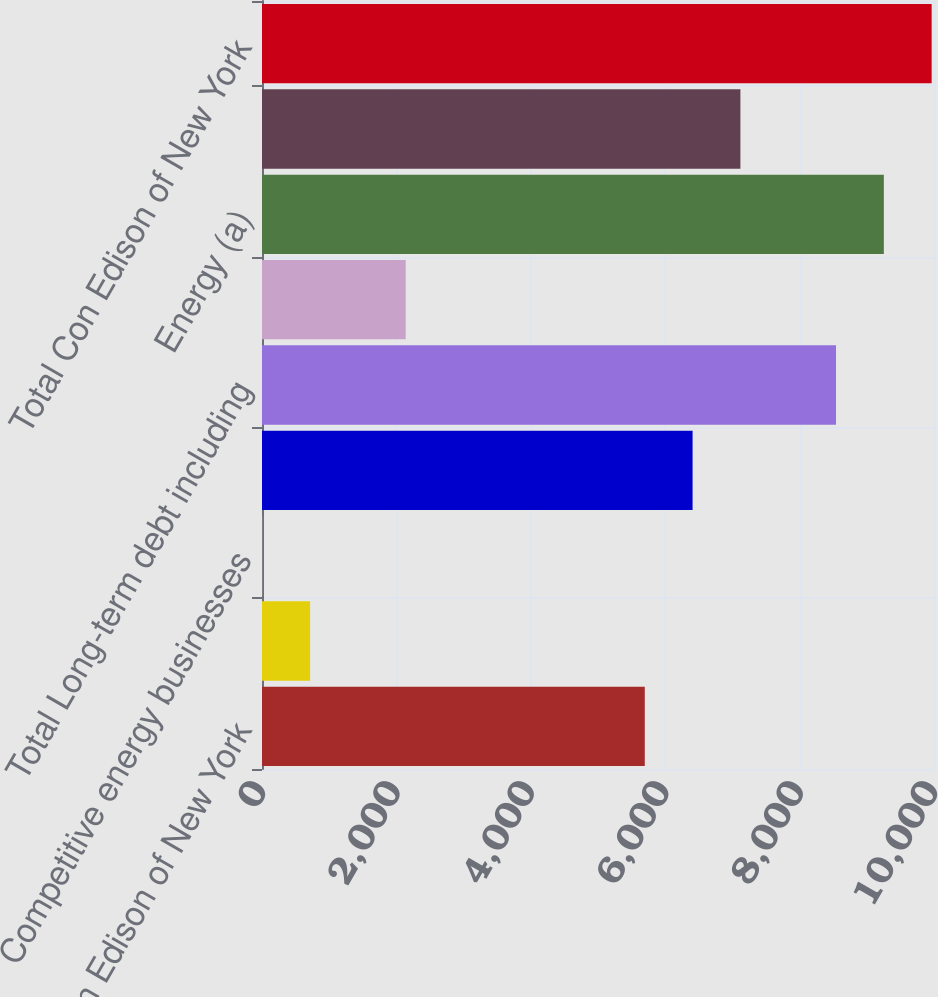<chart> <loc_0><loc_0><loc_500><loc_500><bar_chart><fcel>Con Edison of New York<fcel>O&R<fcel>Competitive energy businesses<fcel>Interest on long-term debt<fcel>Total Long-term debt including<fcel>Total operating leases<fcel>Energy (a)<fcel>Capacity<fcel>Total Con Edison of New York<nl><fcel>5696<fcel>715.5<fcel>4<fcel>6407.5<fcel>8542<fcel>2138.5<fcel>9253.5<fcel>7119<fcel>9965<nl></chart> 